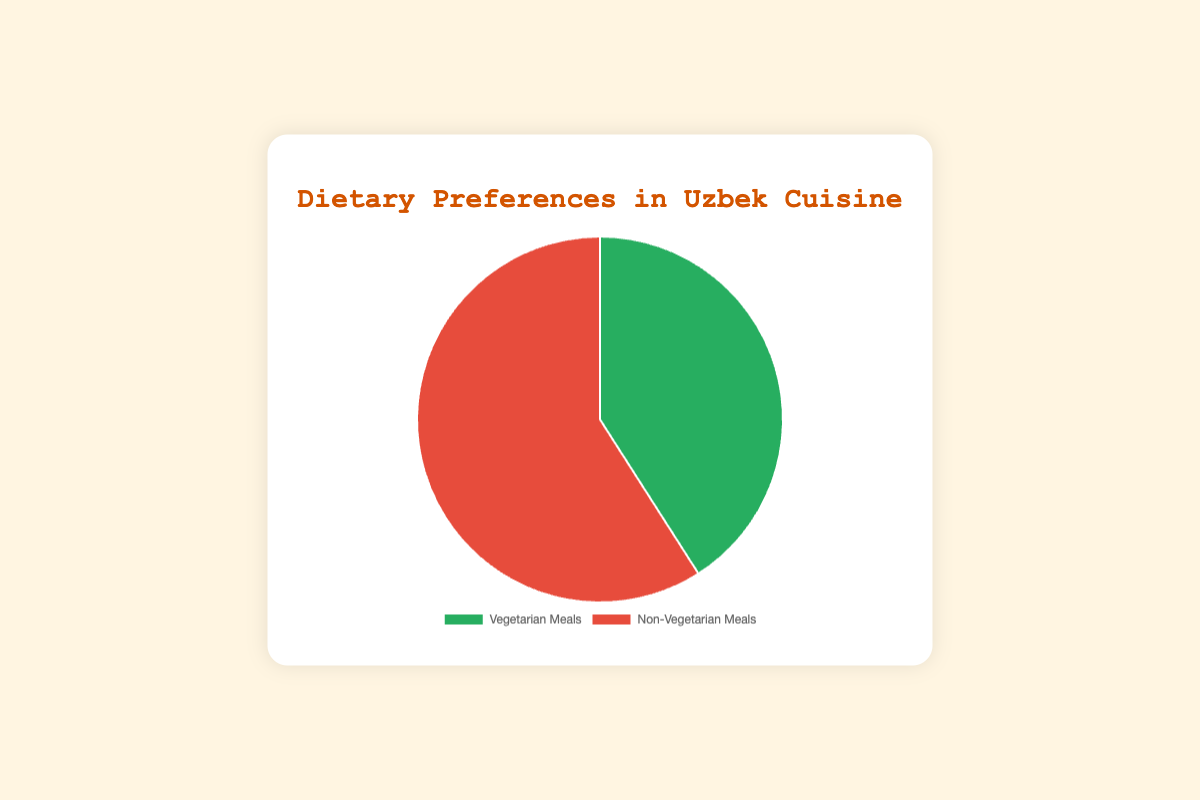What are the total servings of meals shown in the chart? The chart shows two categories of meals: Vegetarian Meals with 430 servings and Non-Vegetarian Meals with 620 servings. Adding these two values together gives the total. \(430 + 620 = 1050\)
Answer: 1050 Which category has a higher number of servings, Vegetarian Meals or Non-Vegetarian Meals? Comparing the two categories, Vegetarian Meals have 430 servings and Non-Vegetarian Meals have 620 servings. Non-Vegetarian Meals have more servings.
Answer: Non-Vegetarian Meals By how much do the servings of Non-Vegetarian Meals exceed the servings of Vegetarian Meals? Subtract the number of Vegetarian Meal servings from the number of Non-Vegetarian Meal servings. \(620 - 430 = 190\)
Answer: 190 What percentage of the total servings are Vegetarian Meals? The total number of servings is 1050. The number of Vegetarian Meal servings is 430. \( \left( \frac{430}{1050} \right) \times 100 \approx 40.95\% \)
Answer: about 41% What is the ratio of Non-Vegetarian Meals to Vegetarian Meals? The number of Non-Vegetarian Meals is 620 and Vegetarian Meals is 430. The ratio is \( \frac{620}{430} \approx 1.44 \) or simplified, 620:430 is approximately 1.44:1.
Answer: approximately 1.44:1 How many more servings of Plov with Lamb are there compared to Lagman? There are 200 servings of Plov with Lamb and 80 servings of Lagman. Subtract \(200 - 80 = 120\)
Answer: 120 If you combine the servings of Plov with Lamb and Plov, how many servings would there be in total? The servings of Plov with Lamb are 200, and Plov is 150. Adding these together gives \(200 + 150 = 350\)
Answer: 350 By how much do the servings of Non-Vegetarian Main Courses exceed the Vegetarian Main Courses? For simplicity, consider Plov, Lagman, and Manti as Vegetarian main courses totaling: \( 150 + 80 + 60 = 290 \). For Non-Vegetarian, consider Plov with Lamb, Shashlik, and Kazakh Kazy totaling: \( 200 + 180 + 50 = 430 \). The difference is \( 430 - 290 = 140 \)
Answer: 140 